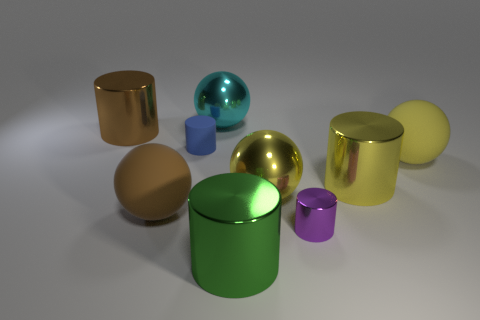Is the number of shiny objects that are behind the large brown sphere less than the number of large objects in front of the cyan thing?
Provide a succinct answer. Yes. What is the material of the cylinder that is in front of the small purple object?
Provide a short and direct response. Metal. There is a large yellow metallic cylinder; are there any brown matte objects behind it?
Give a very brief answer. No. What is the shape of the blue rubber thing?
Offer a terse response. Cylinder. What number of things are either large metallic cylinders in front of the small blue rubber thing or cyan metal spheres?
Offer a very short reply. 3. What is the color of the small rubber object that is the same shape as the large brown shiny object?
Your answer should be very brief. Blue. Is the large cyan sphere made of the same material as the yellow ball to the right of the purple cylinder?
Your response must be concise. No. The tiny matte object has what color?
Provide a succinct answer. Blue. There is a small object that is to the left of the sphere that is behind the metal object left of the cyan shiny thing; what is its color?
Keep it short and to the point. Blue. Does the big brown rubber thing have the same shape as the blue thing that is to the left of the large yellow rubber ball?
Your answer should be compact. No. 